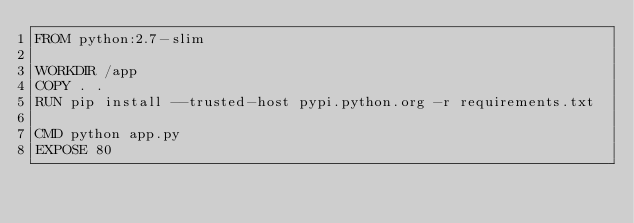Convert code to text. <code><loc_0><loc_0><loc_500><loc_500><_Dockerfile_>FROM python:2.7-slim

WORKDIR /app
COPY . .
RUN pip install --trusted-host pypi.python.org -r requirements.txt 

CMD python app.py
EXPOSE 80
</code> 